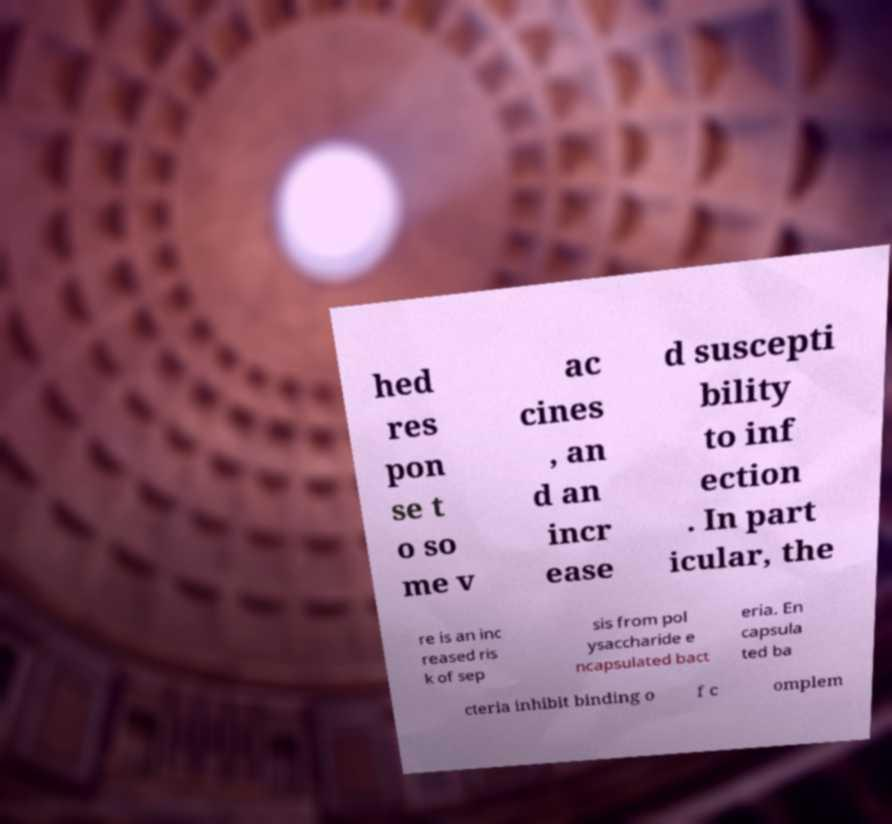Please read and relay the text visible in this image. What does it say? hed res pon se t o so me v ac cines , an d an incr ease d suscepti bility to inf ection . In part icular, the re is an inc reased ris k of sep sis from pol ysaccharide e ncapsulated bact eria. En capsula ted ba cteria inhibit binding o f c omplem 